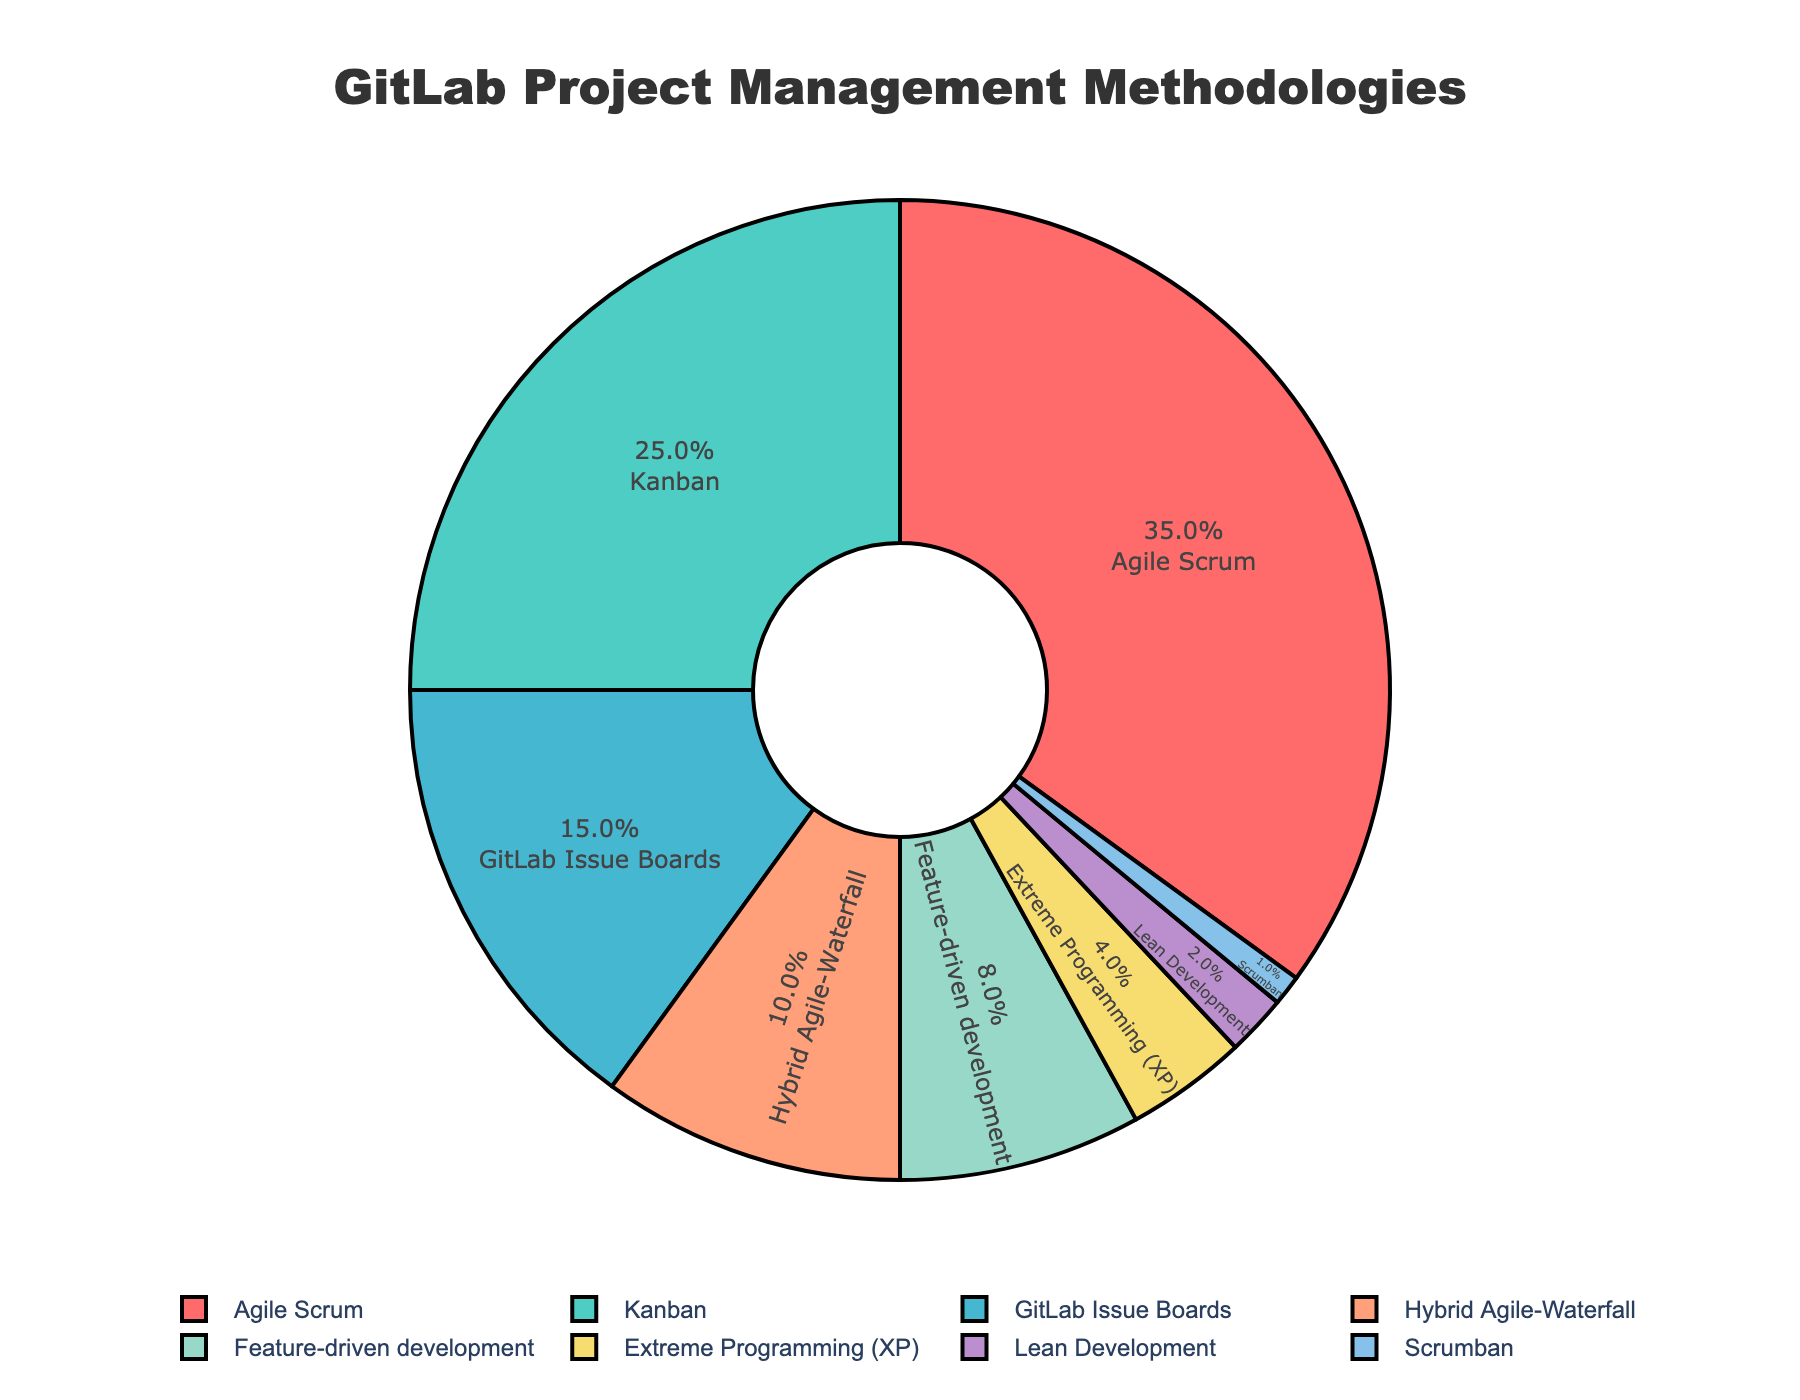Which methodology is used by the highest percentage of development teams? The largest slice in the pie chart represents the methodology used by the highest percentage of teams. By looking at the chart, Agile Scrum has the largest slice.
Answer: Agile Scrum What is the combined percentage of teams using Agile Scrum and Kanban? To find the combined percentage, sum the percentages of teams using Agile Scrum and Kanban. Agile Scrum is 35% and Kanban is 25%, so 35 + 25 equals 60%.
Answer: 60% Which methodology has the smallest representation in the chart? The smallest slice in the pie chart represents the methodology with the least representation. Scrumban has the smallest slice at 1%.
Answer: Scrumban How does the usage of GitLab Issue Boards compare with Feature-driven development? To compare, we look at the percentages of both methodologies. GitLab Issue Boards is at 15% while Feature-driven development is at 8%. GitLab Issue Boards are used by a greater percentage of teams.
Answer: GitLab Issue Boards How much more popular is Agile Scrum compared to Extreme Programming (XP)? Subtract the percentage of Extreme Programming (XP) from Agile Scrum's percentage. Agile Scrum has 35% and XP has 4%, so 35 - 4 equals 31%.
Answer: 31% What percentage of teams uses either Hybrid Agile-Waterfall or Lean Development? Sum the percentages of Hybrid Agile-Waterfall and Lean Development. Hybrid Agile-Waterfall is 10% and Lean Development is 2%, so 10 + 2 equals 12%.
Answer: 12% If you combine the methodologies with less than 10% usage, what is the total percentage? Sum the percentages of methodologies with less than 10% usage: Hybrid Agile-Waterfall (10%), Feature-driven development (8%), Extreme Programming (XP) (4%), Lean Development (2%), Scrumban (1%). So, 10 + 8 + 4 + 2 + 1 equals 25%.
Answer: 25% Which methodologies fall into the middle range (i.e., neither the most nor the least used)? Exclude the methodologies with the highest (Agile Scrum at 35%) and the lowest (Scrumban at 1%) percentages. The middle range methodologies are Kanban (25%), GitLab Issue Boards (15%), Hybrid Agile-Waterfall (10%), Feature-driven development (8%), Extreme Programming (XP) (4%), and Lean Development (2%).
Answer: Kanban, GitLab Issue Boards, Hybrid Agile-Waterfall, Feature-driven development, Extreme Programming (XP), Lean Development How does the usage of Kanban compare to the combined use of Extreme Programming (XP) and Lean Development? First, find the combined percentage of Extreme Programming (XP) and Lean Development, which is 4% + 2% = 6%. Compare this to Kanban’s 25%, clearly showing Kanban is used by a greater percentage of teams.
Answer: Kanban What is the difference between the percentages of teams using Feature-driven development and Hybrid Agile-Waterfall? Subtract the percentage of Hybrid Agile-Waterfall from Feature-driven development. Hybrid Agile-Waterfall has 10% and Feature-driven development has 8%, so 10 - 8 equals 2%.
Answer: 2% 